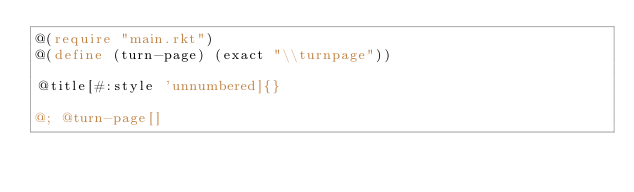<code> <loc_0><loc_0><loc_500><loc_500><_Racket_>@(require "main.rkt")
@(define (turn-page) (exact "\\turnpage"))

@title[#:style 'unnumbered]{}

@; @turn-page[]

</code> 